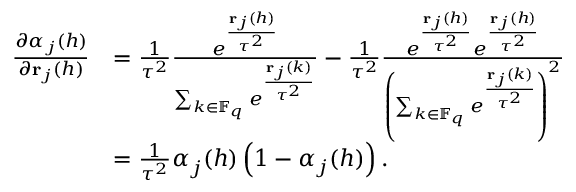<formula> <loc_0><loc_0><loc_500><loc_500>\begin{array} { r l } { \frac { \partial \alpha _ { j } ( h ) } { \partial { r } _ { j } ( h ) } } & { = \frac { 1 } { \tau ^ { 2 } } \frac { e ^ { \frac { { r } _ { j } ( h ) } { \tau ^ { 2 } } } } { \sum _ { k \in \mathbb { F } _ { q } } e ^ { \frac { { r } _ { j } ( k ) } { \tau ^ { 2 } } } } - \frac { 1 } { \tau ^ { 2 } } \frac { e ^ { \frac { { r } _ { j } ( h ) } { \tau ^ { 2 } } } e ^ { \frac { { r } _ { j } ( h ) } { \tau ^ { 2 } } } } { \left ( \sum _ { k \in \mathbb { F } _ { q } } e ^ { \frac { { r } _ { j } ( k ) } { \tau ^ { 2 } } } \right ) ^ { 2 } } } \\ & { = \frac { 1 } { \tau ^ { 2 } } \alpha _ { j } ( h ) \left ( 1 - \alpha _ { j } ( h ) \right ) . } \end{array}</formula> 